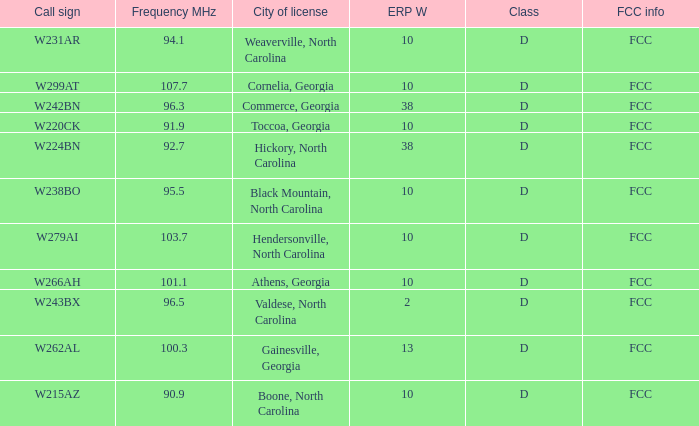What is the FCC frequency for the station w262al which has a Frequency MHz larger than 92.7? FCC. 